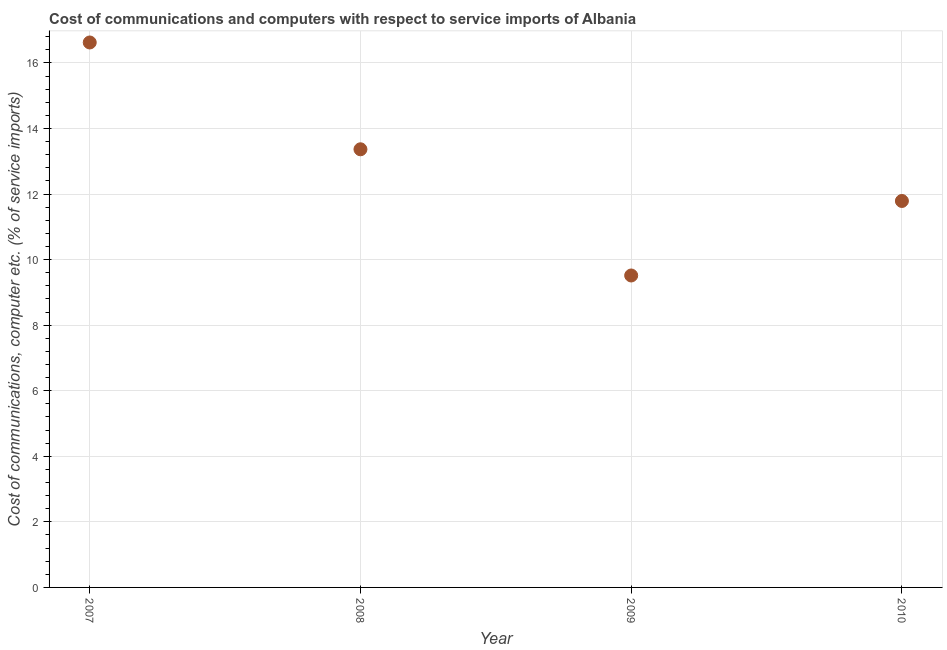What is the cost of communications and computer in 2010?
Make the answer very short. 11.79. Across all years, what is the maximum cost of communications and computer?
Keep it short and to the point. 16.62. Across all years, what is the minimum cost of communications and computer?
Your answer should be compact. 9.52. In which year was the cost of communications and computer minimum?
Offer a terse response. 2009. What is the sum of the cost of communications and computer?
Provide a short and direct response. 51.29. What is the difference between the cost of communications and computer in 2007 and 2010?
Keep it short and to the point. 4.84. What is the average cost of communications and computer per year?
Ensure brevity in your answer.  12.82. What is the median cost of communications and computer?
Your answer should be compact. 12.58. What is the ratio of the cost of communications and computer in 2008 to that in 2009?
Give a very brief answer. 1.4. Is the cost of communications and computer in 2009 less than that in 2010?
Make the answer very short. Yes. What is the difference between the highest and the second highest cost of communications and computer?
Ensure brevity in your answer.  3.26. Is the sum of the cost of communications and computer in 2009 and 2010 greater than the maximum cost of communications and computer across all years?
Give a very brief answer. Yes. What is the difference between the highest and the lowest cost of communications and computer?
Offer a terse response. 7.11. In how many years, is the cost of communications and computer greater than the average cost of communications and computer taken over all years?
Give a very brief answer. 2. Does the cost of communications and computer monotonically increase over the years?
Offer a terse response. No. How many dotlines are there?
Your response must be concise. 1. Are the values on the major ticks of Y-axis written in scientific E-notation?
Offer a terse response. No. Does the graph contain grids?
Ensure brevity in your answer.  Yes. What is the title of the graph?
Offer a terse response. Cost of communications and computers with respect to service imports of Albania. What is the label or title of the Y-axis?
Your answer should be compact. Cost of communications, computer etc. (% of service imports). What is the Cost of communications, computer etc. (% of service imports) in 2007?
Ensure brevity in your answer.  16.62. What is the Cost of communications, computer etc. (% of service imports) in 2008?
Offer a terse response. 13.37. What is the Cost of communications, computer etc. (% of service imports) in 2009?
Provide a short and direct response. 9.52. What is the Cost of communications, computer etc. (% of service imports) in 2010?
Provide a short and direct response. 11.79. What is the difference between the Cost of communications, computer etc. (% of service imports) in 2007 and 2008?
Provide a succinct answer. 3.26. What is the difference between the Cost of communications, computer etc. (% of service imports) in 2007 and 2009?
Your answer should be compact. 7.11. What is the difference between the Cost of communications, computer etc. (% of service imports) in 2007 and 2010?
Your response must be concise. 4.84. What is the difference between the Cost of communications, computer etc. (% of service imports) in 2008 and 2009?
Ensure brevity in your answer.  3.85. What is the difference between the Cost of communications, computer etc. (% of service imports) in 2008 and 2010?
Ensure brevity in your answer.  1.58. What is the difference between the Cost of communications, computer etc. (% of service imports) in 2009 and 2010?
Provide a short and direct response. -2.27. What is the ratio of the Cost of communications, computer etc. (% of service imports) in 2007 to that in 2008?
Provide a short and direct response. 1.24. What is the ratio of the Cost of communications, computer etc. (% of service imports) in 2007 to that in 2009?
Your answer should be very brief. 1.75. What is the ratio of the Cost of communications, computer etc. (% of service imports) in 2007 to that in 2010?
Provide a succinct answer. 1.41. What is the ratio of the Cost of communications, computer etc. (% of service imports) in 2008 to that in 2009?
Your response must be concise. 1.41. What is the ratio of the Cost of communications, computer etc. (% of service imports) in 2008 to that in 2010?
Your answer should be compact. 1.13. What is the ratio of the Cost of communications, computer etc. (% of service imports) in 2009 to that in 2010?
Keep it short and to the point. 0.81. 